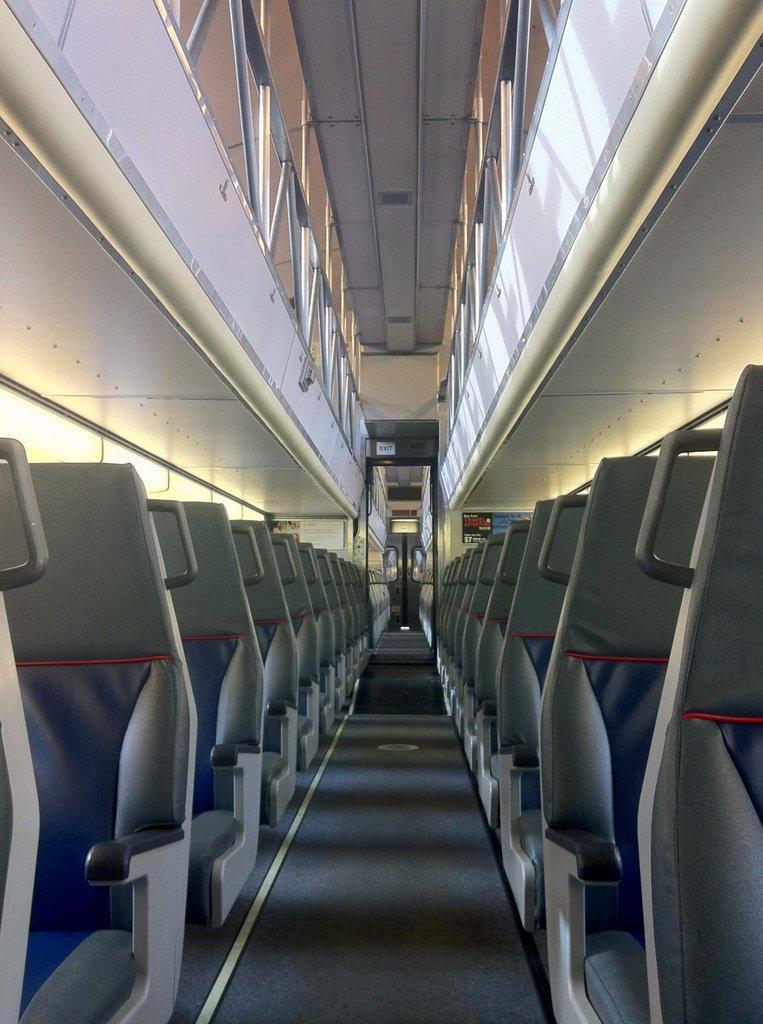Can you describe this image briefly? In this picture I can see a number of sitting chairs. 